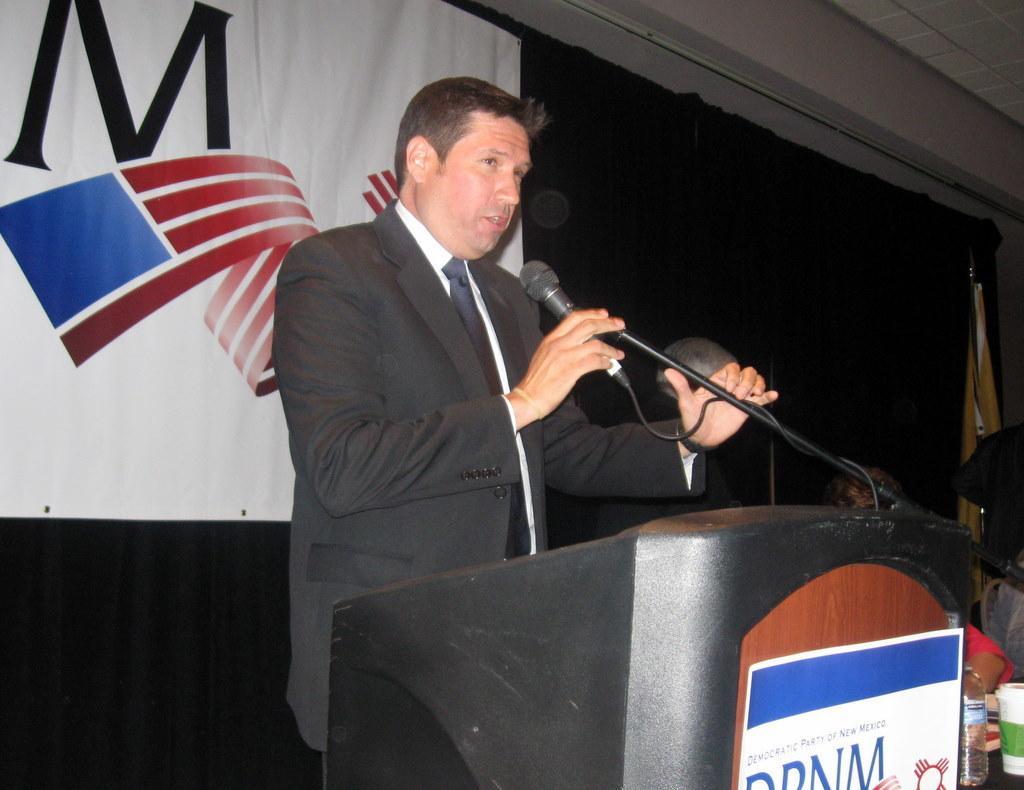Describe this image in one or two sentences. In this picture there is a man speaking holding a microphone in his right hand and there are another person sitting beside him. 